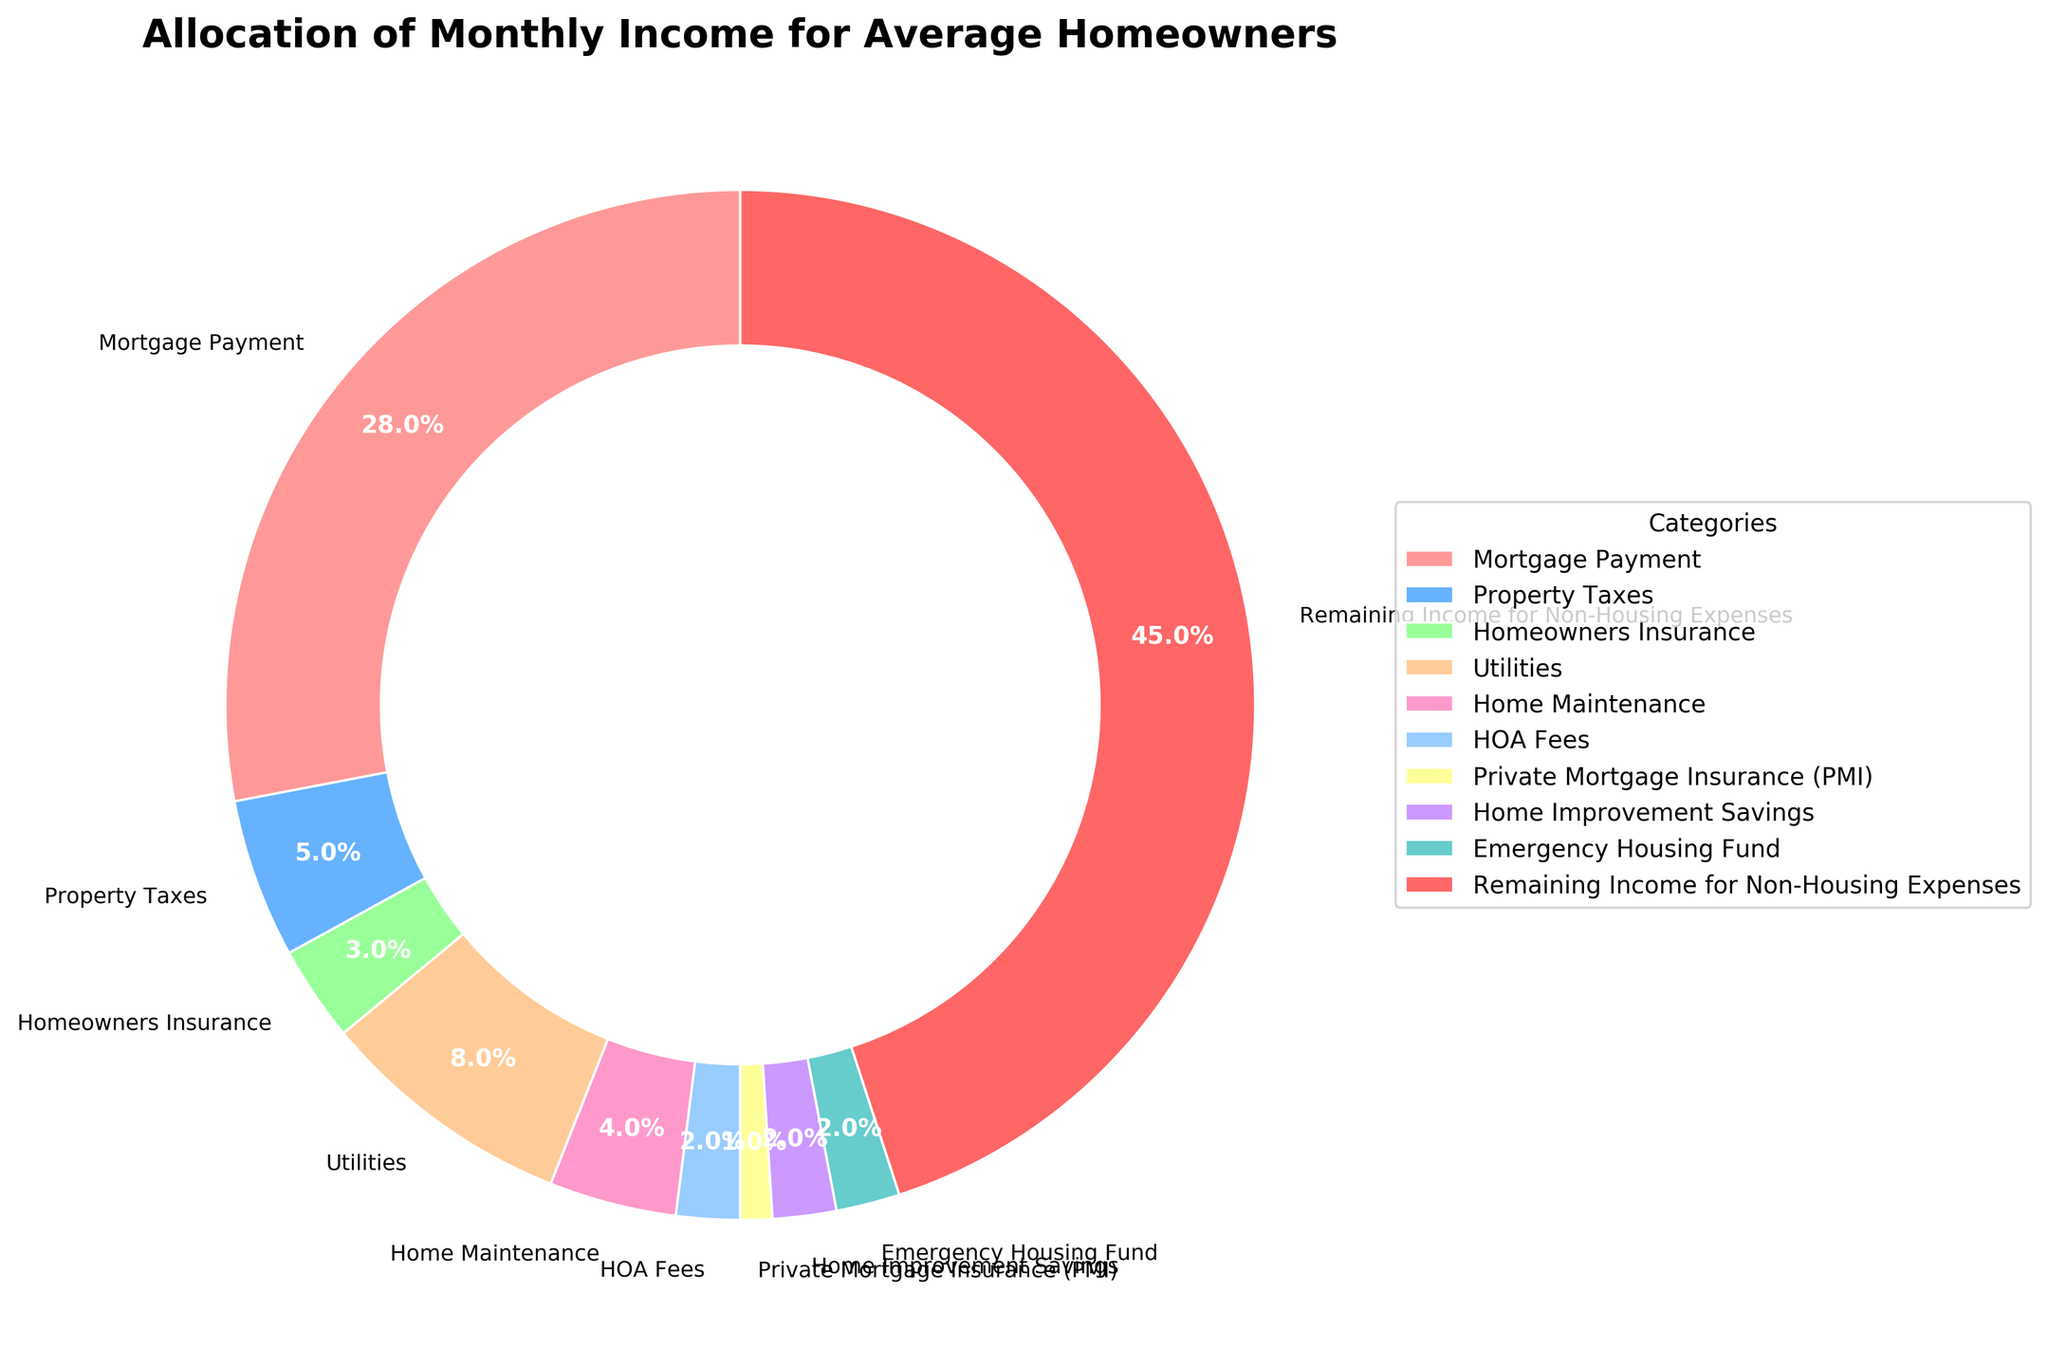What percentage of the monthly income is allocated to fixed expenses like Mortgage Payment, Property Taxes, and Homeowners Insurance? To find the total percentage allocated to fixed expenses, sum the percentages of Mortgage Payment (28%), Property Taxes (5%), and Homeowners Insurance (3%). So, 28 + 5 + 3 = 36%
Answer: 36% Which category receives the smallest percentage of the monthly income? By observing the pie chart, the category with the smallest percentage is Private Mortgage Insurance (PMI) at 1%
Answer: Private Mortgage Insurance (PMI) How much more is allocated to Utilities compared to Home Maintenance? Utilities receive 8% of the monthly income, and Home Maintenance receives 4%. The difference is found by subtracting the percentage of Home Maintenance from Utilities, so 8 - 4 = 4%
Answer: 4% Which category has the highest allocation, and how much more is it compared to the category with the second highest allocation? The category with the highest allocation is Remaining Income for Non-Housing Expenses at 45%, and the second highest is Mortgage Payment at 28%. The difference is 45 - 28 = 17%
Answer: Remaining Income for Non-Housing Expenses, 17% What percentage is allocated to less immediate housing-related expenses like Home Improvement Savings and Emergency Housing Fund together? Sum up the percentages allocated to Home Improvement Savings (2%) and Emergency Housing Fund (2%). So, 2 + 2 = 4%
Answer: 4% How many categories have a percentage allocation less than 5%? By reviewing the pie chart, the categories with allocations less than 5% are Homeowners Insurance (3%), Home Maintenance (4%), HOA Fees (2%), Private Mortgage Insurance (PMI) (1%), Home Improvement Savings (2%), and Emergency Housing Fund (2%). Count them to get 6 categories
Answer: 6 If the total monthly income is $5,000, how much money is allocated to Mortgage Payment? To find the amount allocated to Mortgage Payment, calculate 28% of $5,000. Multiply 5000 by 0.28, resulting in $1,400
Answer: $1,400 By how much percentage does the allocation for Remaining Income for Non-Housing Expenses exceed the combined allocation for Homeowners Insurance and Utilities? Combine the percentages for Homeowners Insurance (3%) and Utilities (8%), so 3 + 8 = 11%. Subtract this from the percentage for Remaining Income for Non-Housing Expenses, 45 - 11 = 34%
Answer: 34% 